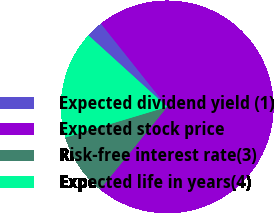<chart> <loc_0><loc_0><loc_500><loc_500><pie_chart><fcel>Expected dividend yield (1)<fcel>Expected stock price<fcel>Risk-free interest rate(3)<fcel>Expected life in years(4)<nl><fcel>2.58%<fcel>71.57%<fcel>9.48%<fcel>16.38%<nl></chart> 